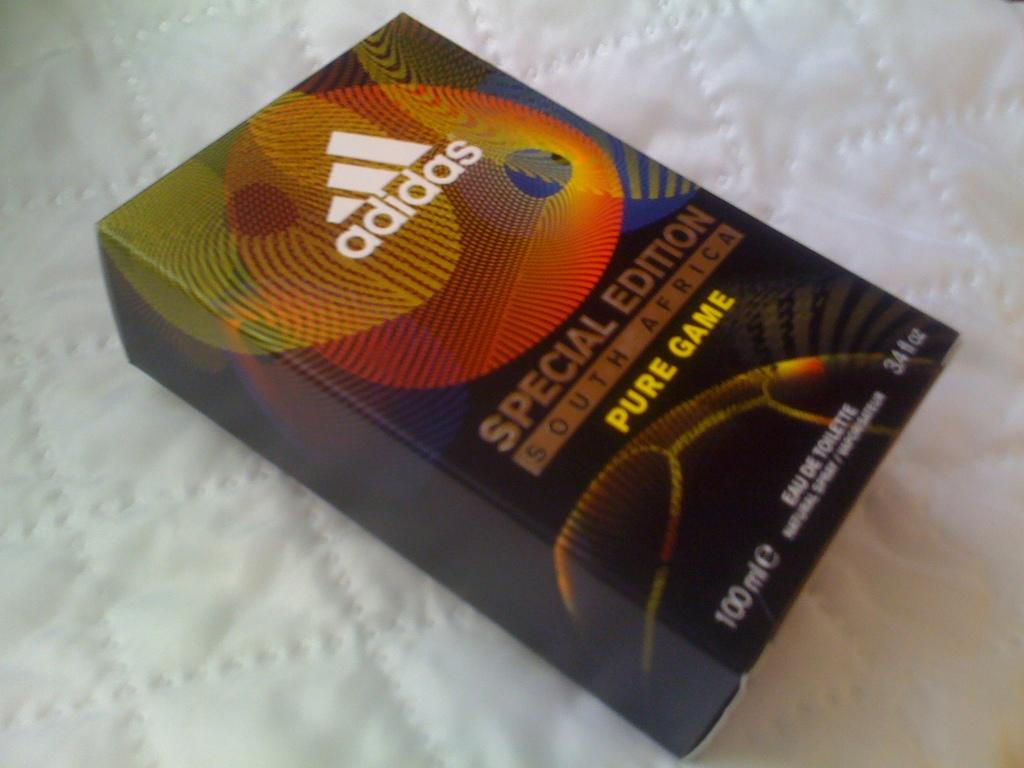Provide a one-sentence caption for the provided image. Adidas special edition south african pure game book. 